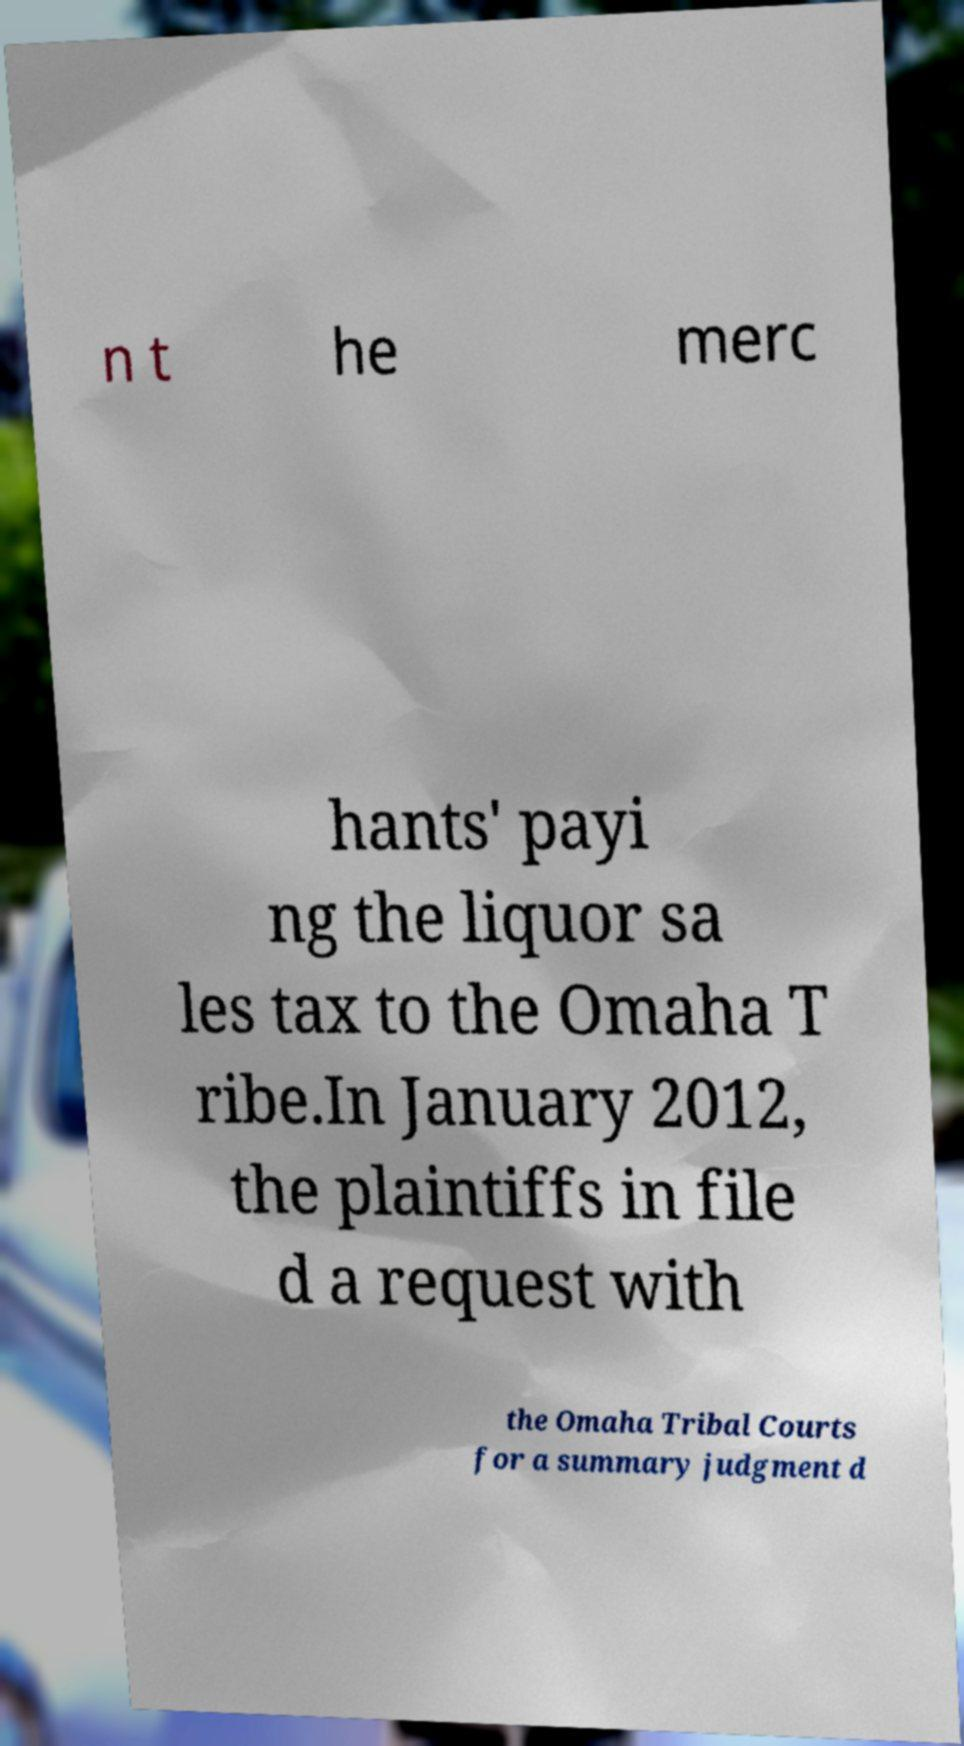Please read and relay the text visible in this image. What does it say? n t he merc hants' payi ng the liquor sa les tax to the Omaha T ribe.In January 2012, the plaintiffs in file d a request with the Omaha Tribal Courts for a summary judgment d 